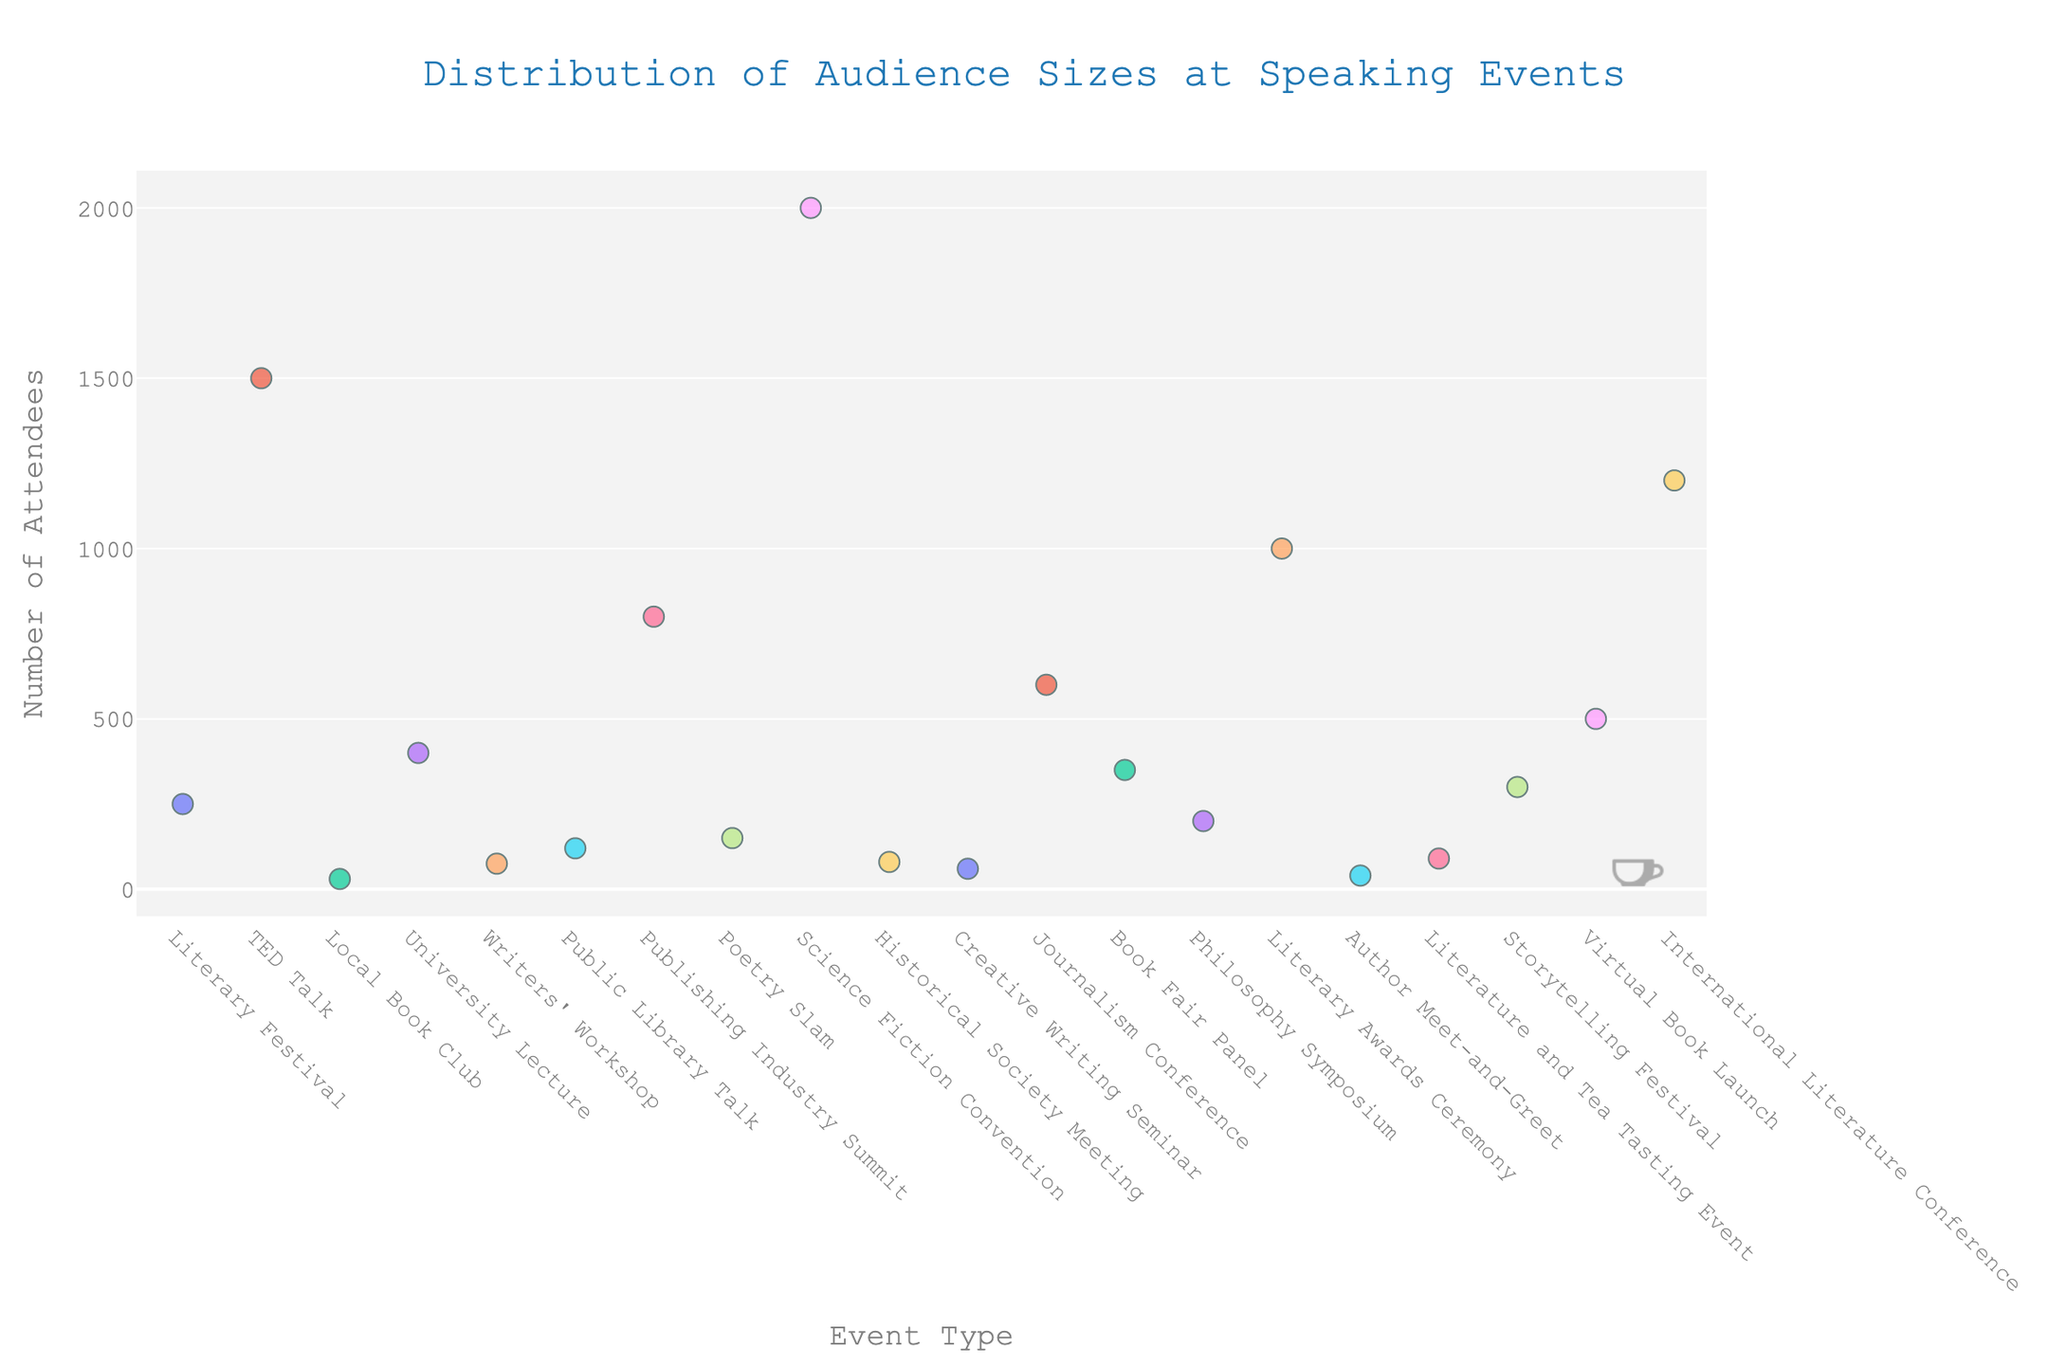What is the overall title of the strip plot? The title is located at the top of the plot and typically summarizes what the visualization is about. It is written in a larger font size for easy recognition.
Answer: Distribution of Audience Sizes at Speaking Events Which conference type has the largest audience size? To find the largest audience size, locate the highest point on the y-axis and see the corresponding conference type on the x-axis. The highest value is 2000, which corresponds to the Science Fiction Convention.
Answer: Science Fiction Convention How many conference types have audience sizes equal to or greater than 1000? Check the y-axis values to see which conference types have markers at or above 1000. The points at this level belong to TED Talk (1500), Literary Awards Ceremony (1000), International Literature Conference (1200), and Science Fiction Convention (2000). Count these points.
Answer: 4 What is the difference in audience size between the smallest and the largest events? Identify the smallest event size (30, for the Local Book Club) and the largest event size (2000, for the Science Fiction Convention). Subtract the smallest value from the largest: 2000 - 30.
Answer: 1970 What is the average audience size across all conference types? Sum the audience sizes from all conference types: 250 + 1500 + 30 + 400 + 75 + 120 + 800 + 150 + 2000 + 80 + 60 + 600 + 350 + 200 + 1000 + 40 + 90 + 300 + 500 + 1200 = 11245. Divide this by the number of conference types (20): 11245 / 20.
Answer: 562.25 Which conference type has the smallest audience size? Look for the lowest point along the y-axis and check the corresponding conference type on the x-axis. The smallest value is 30, which corresponds to the Local Book Club.
Answer: Local Book Club How are the audience sizes distributed across different conference types? Observe the spread and clustering of the points along the y-axis for each conference type on the x-axis. The distribution shows a wide range from 30 to 2000, indicating significant variability in audience sizes.
Answer: Wide range from 30 to 2000 Which two conference types have the closest audience sizes around 100? Identify conference types with audience sizes near 100 by checking points close to that value on the y-axis. Public Library Talk (120) and Historical Society Meeting (80) are closest to each other around 100.
Answer: Public Library Talk and Historical Society Meeting What is the median audience size across all conference types? Sort the audience sizes and find the middle value. Ordered sizes: 30, 40, 60, 75, 80, 90, 120, 150, 200, 250, 300, 350, 400, 500, 600, 800, 1000, 1200, 1500, 2000. The two middle values are 200 and 250. The median is the average of these two: (200 + 250) / 2.
Answer: 225 Which conference type has a significant outlier compared to the others? Look for points significantly higher than the rest. The Science Fiction Convention (2000) stands out as an outlier compared to other conference types.
Answer: Science Fiction Convention 